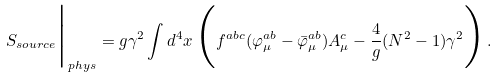Convert formula to latex. <formula><loc_0><loc_0><loc_500><loc_500>S _ { s o u r c e } \Big | _ { p h y s } = g \gamma ^ { 2 } \int { d ^ { 4 } x } \, \Big ( f ^ { a b c } ( \varphi ^ { a b } _ { \mu } - \bar { \varphi } ^ { a b } _ { \mu } ) A ^ { c } _ { \mu } - \frac { 4 } { g } ( N ^ { 2 } - 1 ) \gamma ^ { 2 } \Big ) \, .</formula> 